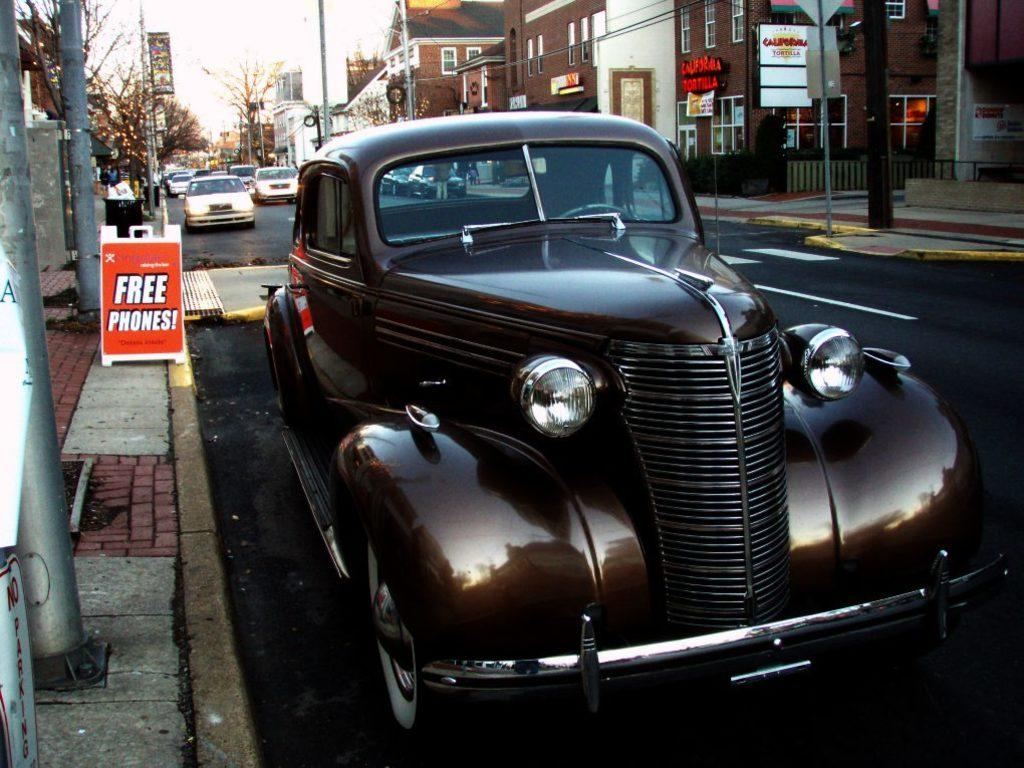<image>
Summarize the visual content of the image. An old looking car with a billboard reading 'free phones' in the background. 